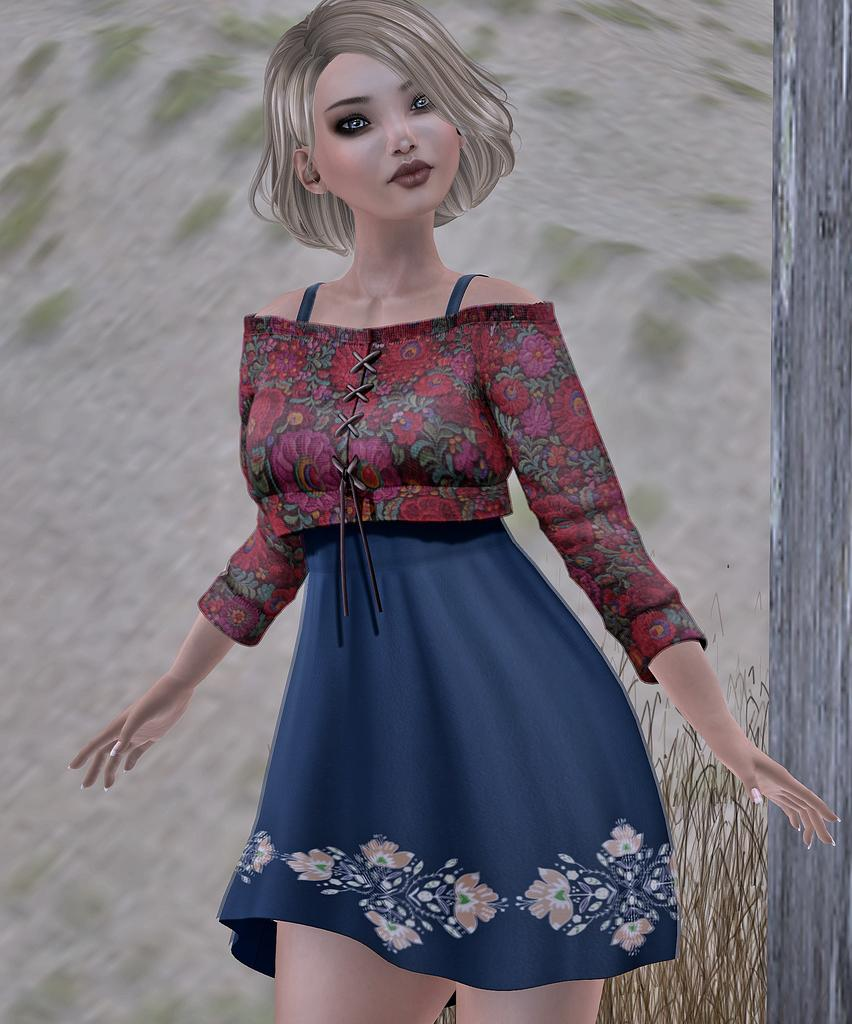What type of image is being described? The image is a graphic. Who or what is the main subject of the image? There is a woman in the center of the image. What type of vegetation is present on the right side of the image? There is grass on the right side of the image. What other natural element is present on the right side of the image? There is a tree on the right side of the image. What type of quill is being used by the woman in the image? There is no quill present in the image; it is a graphic featuring a woman and natural elements. 